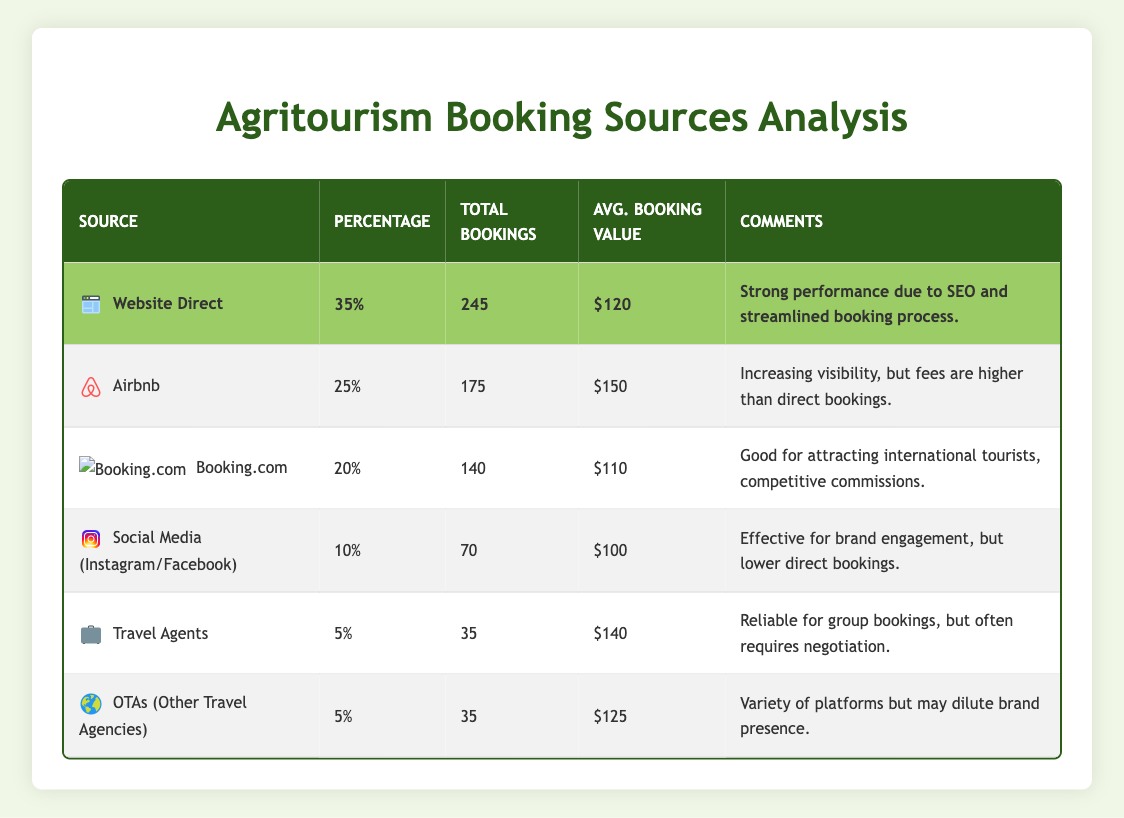What is the total number of bookings from the "Website Direct" source? The "Website Direct" source has a total of 245 bookings listed in the table.
Answer: 245 Which booking source has the highest average booking value? The average booking value for "Airbnb" is $150, which is the highest compared to other sources listed in the table.
Answer: Airbnb What percentage of total bookings comes from "Social Media"? The table shows that "Social Media" accounts for 10% of total bookings.
Answer: 10% What is the total number of bookings from "Travel Agents" and "OTAs"? The total bookings from "Travel Agents" is 35, and from "OTAs", it is also 35. Adding these together gives 35 + 35 = 70 total bookings from both sources.
Answer: 70 Which source has the lowest percentage of bookings? "Travel Agents" and "OTAs" both have the lowest percentage of bookings at 5%.
Answer: Travel Agents and OTAs Is the average booking value for "Booking.com" less than $120? The average booking value for "Booking.com" is $110, which is indeed less than $120.
Answer: Yes If we consider only the top three sources, what is their combined total bookings? The top three sources are "Website Direct" (245), "Airbnb" (175), and "Booking.com" (140). Adding these gives 245 + 175 + 140 = 560 total bookings from the top three sources.
Answer: 560 What is the difference in total bookings between "Airbnb" and "Booking.com"? "Airbnb" has 175 total bookings and "Booking.com" has 140. The difference is 175 - 140 = 35.
Answer: 35 Is it true that the "Website Direct" source made more bookings than the combined total of "Social Media", "Travel Agents", and "OTAs"? The total for "Social Media" is 70, "Travel Agents" is 35, and "OTAs" is 35. Adding those gives 70 + 35 + 35 = 140. Since "Website Direct" has 245 bookings, it is true that it has more bookings.
Answer: Yes What is the average booking value for all the sources combined? The total average booking values for each source are as follows: (120 + 150 + 110 + 100 + 140 + 125) = 745. There are six sources; therefore, the average is 745 / 6 ≈ 124.17.
Answer: 124.17 